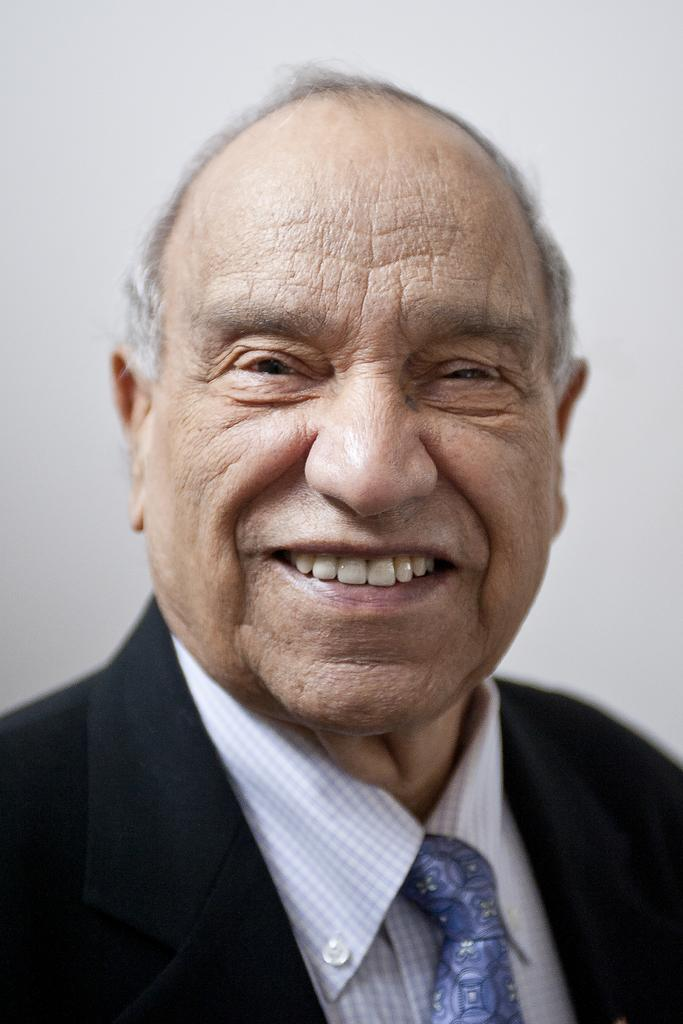What is present in the image? There is a person in the image. How is the person's expression in the image? The person is smiling. What can be seen in the background of the image? There is a wall in the background of the image. What type of cork can be seen in the image? There is no cork present in the image. What season is depicted in the image? The provided facts do not mention any season, so it cannot be determined from the image. 